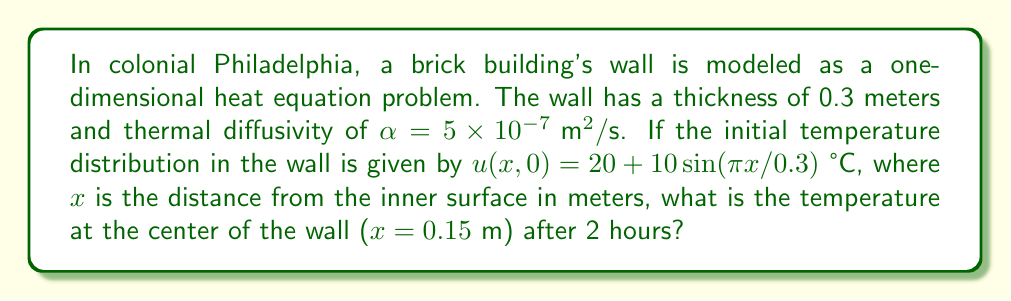Can you solve this math problem? To solve this problem, we'll use the solution to the one-dimensional heat equation with insulated boundary conditions:

1) The general solution for the heat equation is:
   $$u(x,t) = \sum_{n=1}^{\infty} B_n \sin(\frac{n\pi x}{L})e^{-\alpha(\frac{n\pi}{L})^2t}$$

2) In this case, $L = 0.3$ m and the initial condition is:
   $$u(x,0) = 20 + 10\sin(\frac{\pi x}{0.3})$$

3) Comparing the initial condition with the general solution, we see that only the first term ($n=1$) is present, with $B_1 = 10$ and a constant term of 20.

4) Therefore, our solution is:
   $$u(x,t) = 20 + 10\sin(\frac{\pi x}{0.3})e^{-\alpha(\frac{\pi}{0.3})^2t}$$

5) We need to evaluate this at $x = 0.15$ m and $t = 2$ hours = 7200 seconds:
   $$u(0.15, 7200) = 20 + 10\sin(\frac{\pi \cdot 0.15}{0.3})e^{-(5 \times 10^{-7})(\frac{\pi}{0.3})^2 \cdot 7200}$$

6) Simplify:
   $$u(0.15, 7200) = 20 + 10\sin(\frac{\pi}{2})e^{-0.1257}$$
   $$= 20 + 10 \cdot 1 \cdot 0.8818$$
   $$= 20 + 8.818$$
   $$= 28.818 \text{ °C}$$
Answer: 28.82 °C 